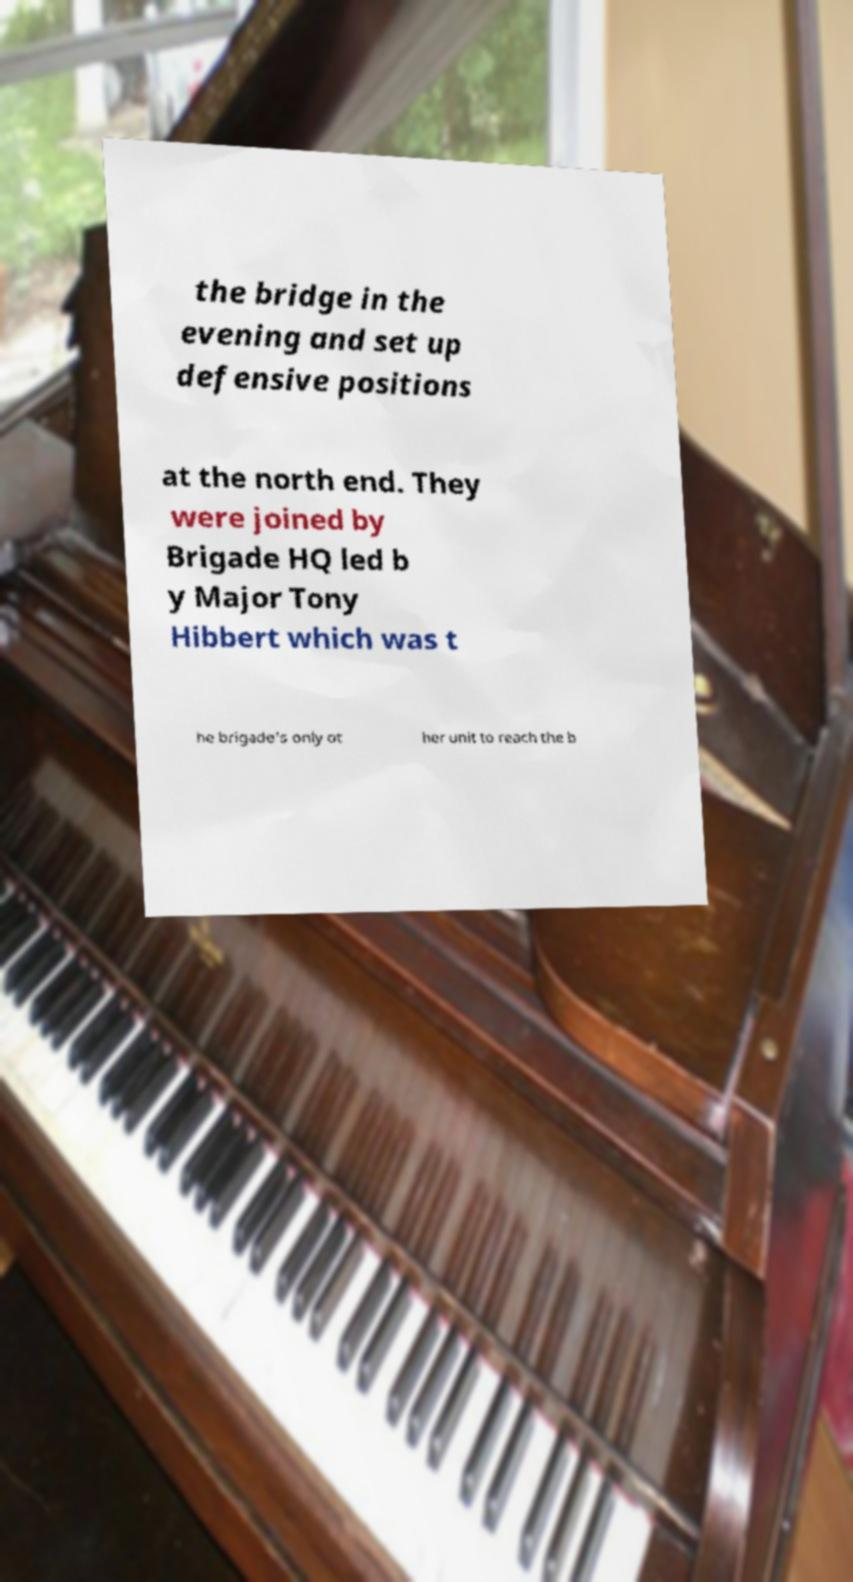Can you read and provide the text displayed in the image?This photo seems to have some interesting text. Can you extract and type it out for me? the bridge in the evening and set up defensive positions at the north end. They were joined by Brigade HQ led b y Major Tony Hibbert which was t he brigade's only ot her unit to reach the b 